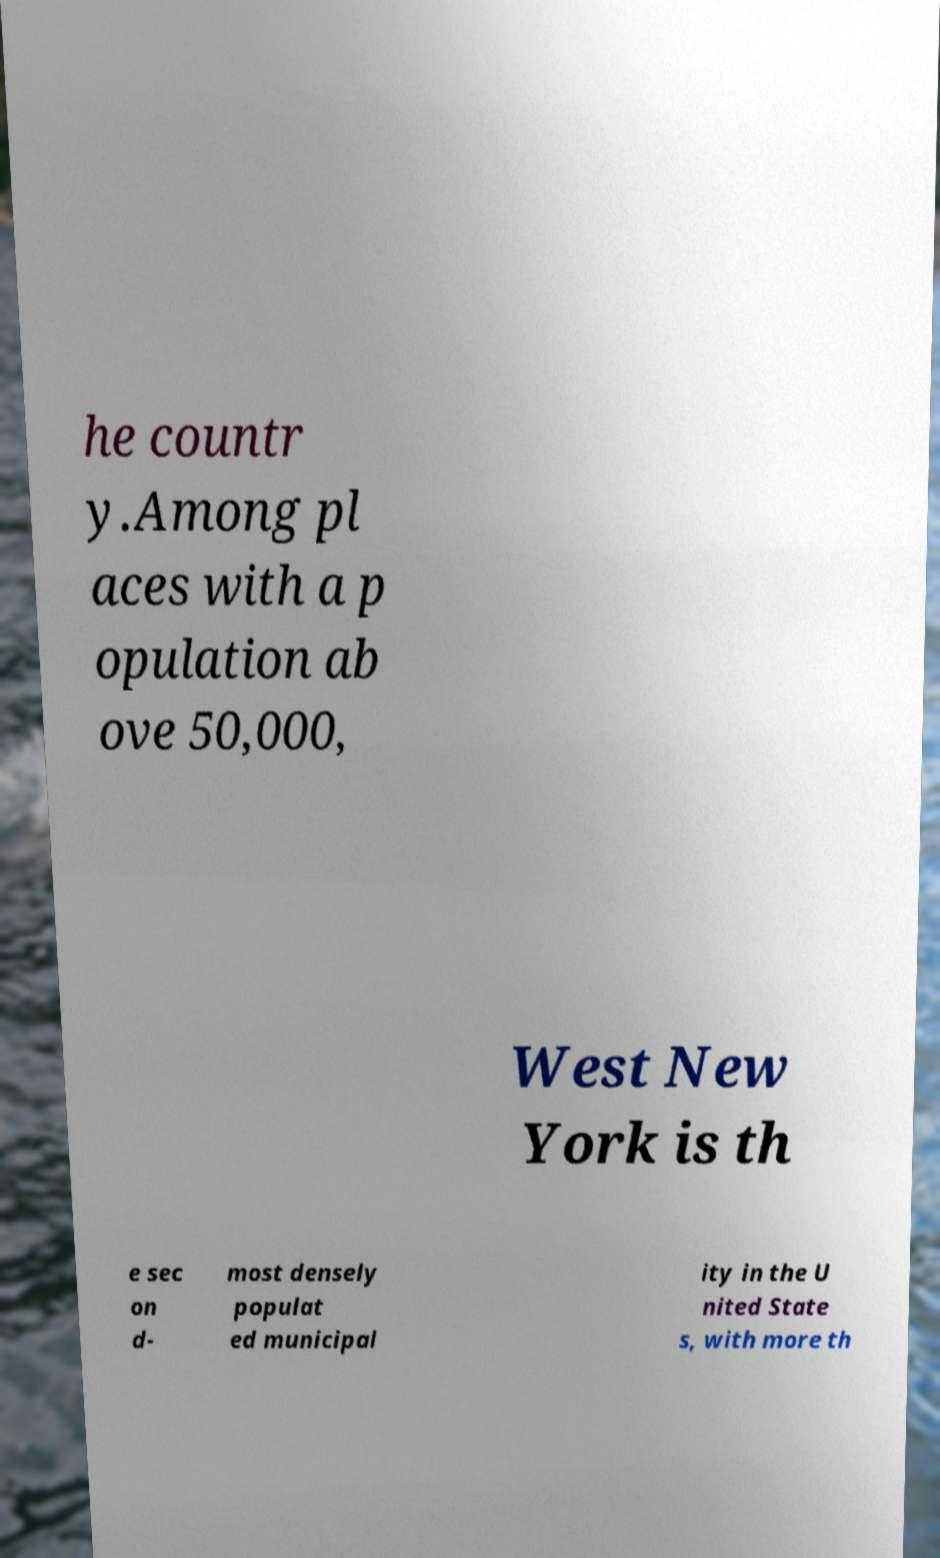Please identify and transcribe the text found in this image. he countr y.Among pl aces with a p opulation ab ove 50,000, West New York is th e sec on d- most densely populat ed municipal ity in the U nited State s, with more th 